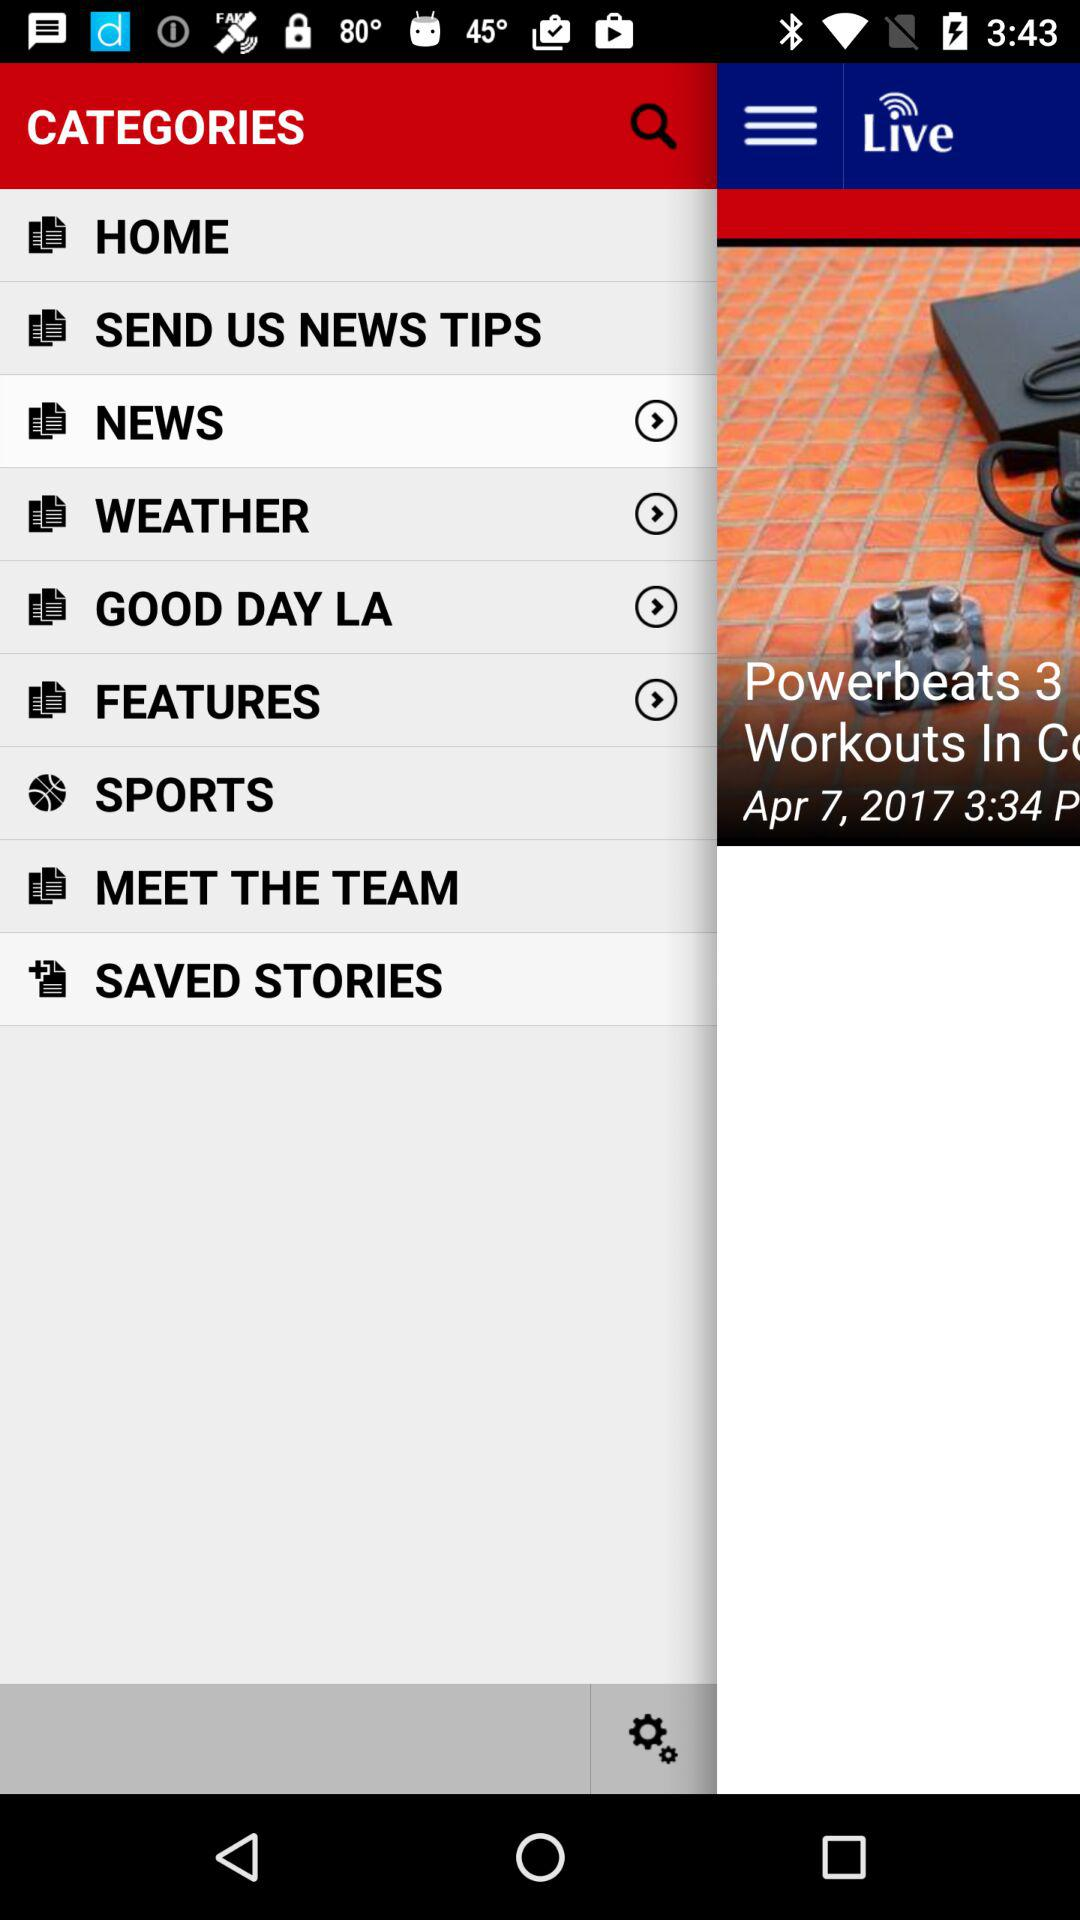Which date is shown on the screen? The shown date is April 7, 2017. 